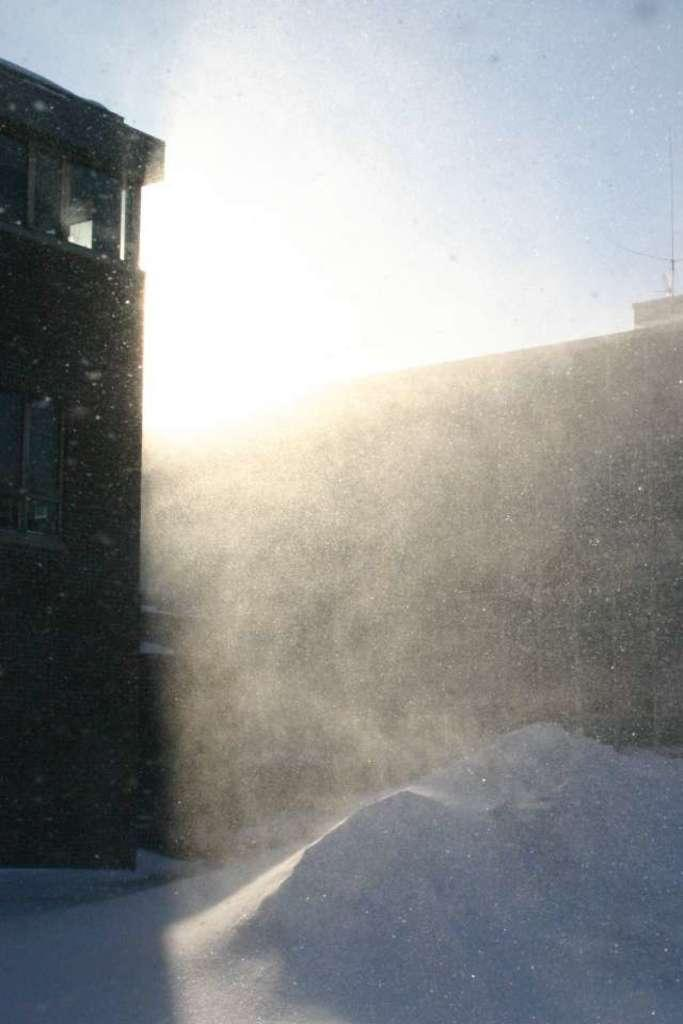What type of weather condition is depicted in the image? There is snow in the front of the image, indicating a snowy or wintry scene. What structure is located on the left side of the image? There is a building on the left side of the image. What is visible at the top of the image? The sky is visible at the top of the image. Can you see a knot tied around the building in the image? There is no knot present in the image, and it is not tied around the building. What type of vessel is floating in the stream in the image? There is no stream or vessel present in the image; it features snow and a building. 